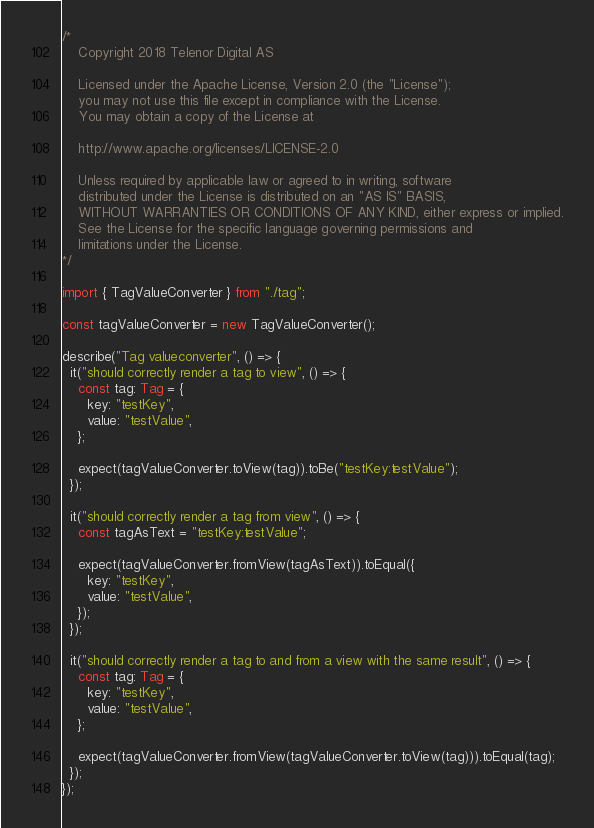Convert code to text. <code><loc_0><loc_0><loc_500><loc_500><_TypeScript_>/*
	Copyright 2018 Telenor Digital AS

	Licensed under the Apache License, Version 2.0 (the "License");
	you may not use this file except in compliance with the License.
	You may obtain a copy of the License at

	http://www.apache.org/licenses/LICENSE-2.0

	Unless required by applicable law or agreed to in writing, software
	distributed under the License is distributed on an "AS IS" BASIS,
	WITHOUT WARRANTIES OR CONDITIONS OF ANY KIND, either express or implied.
	See the License for the specific language governing permissions and
	limitations under the License.
*/

import { TagValueConverter } from "./tag";

const tagValueConverter = new TagValueConverter();

describe("Tag valueconverter", () => {
  it("should correctly render a tag to view", () => {
    const tag: Tag = {
      key: "testKey",
      value: "testValue",
    };

    expect(tagValueConverter.toView(tag)).toBe("testKey:testValue");
  });

  it("should correctly render a tag from view", () => {
    const tagAsText = "testKey:testValue";

    expect(tagValueConverter.fromView(tagAsText)).toEqual({
      key: "testKey",
      value: "testValue",
    });
  });

  it("should correctly render a tag to and from a view with the same result", () => {
    const tag: Tag = {
      key: "testKey",
      value: "testValue",
    };

    expect(tagValueConverter.fromView(tagValueConverter.toView(tag))).toEqual(tag);
  });
});
</code> 